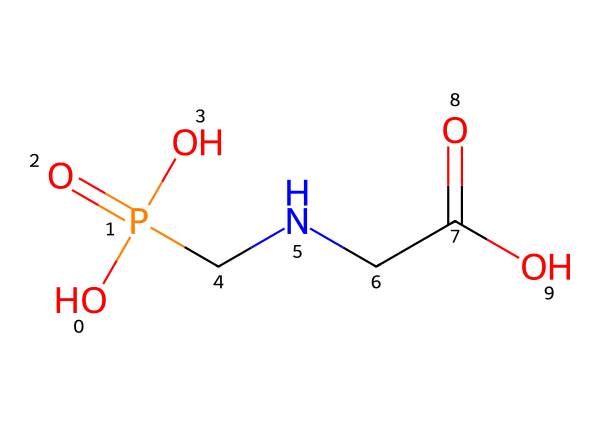What is the molecular formula of glyphosate? To determine the molecular formula, we need to count the different types of atoms represented in the SMILES. In this case, there are 3 Carbon (C), 8 Hydrogen (H), 1 Nitrogen (N), 4 Oxygen (O), and 1 Phosphorus (P) atom. Therefore, the molecular formula can be constructed as C3H8N1O4P.
Answer: C3H8N1O4P How many carbon atoms are in glyphosate? By inspecting the SMILES notation, we can identify the carbon atoms (C). There are 3 occurrences of the letter "C" in the structure, indicating that there are 3 carbon atoms present in glyphosate.
Answer: 3 What type of functional groups are present in glyphosate? Analyzing the structure, we identify the presence of amine (-NH), carboxylic acid (-COOH), and phosphate (-PO4) functional groups. These functional groups are integral to its chemical properties and interactions as a pesticide.
Answer: amine, carboxylic acid, phosphate What is the total number of oxygen atoms in glyphosate? Counting the number of oxygen atoms present in the SMILES notation, we see that there are four occurrences of the letter "O". Hence, glyphosate contains a total of 4 oxygen atoms.
Answer: 4 Which functional group gives glyphosate its herbicidal properties? Glyphosate's herbicidal activity primarily stems from the phosphonate group (phosphate). This functional group interacts specifically with key biological pathways in plants, disrupting their growth processes.
Answer: phosphonate Is glyphosate a polar or nonpolar molecule? Examining the structure, glyphosate contains multiple polar functional groups, such as carboxylic acids and phosphonates. These increase its overall polarity, making glyphosate a polar molecule.
Answer: polar 